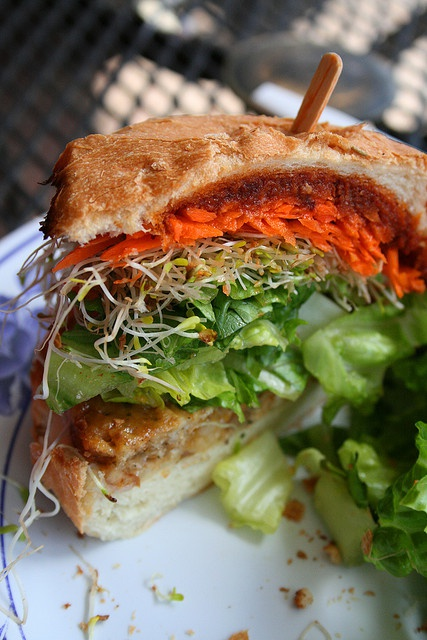Describe the objects in this image and their specific colors. I can see sandwich in black, olive, maroon, brown, and tan tones, broccoli in black, darkgreen, and olive tones, and carrot in black, red, brown, and maroon tones in this image. 